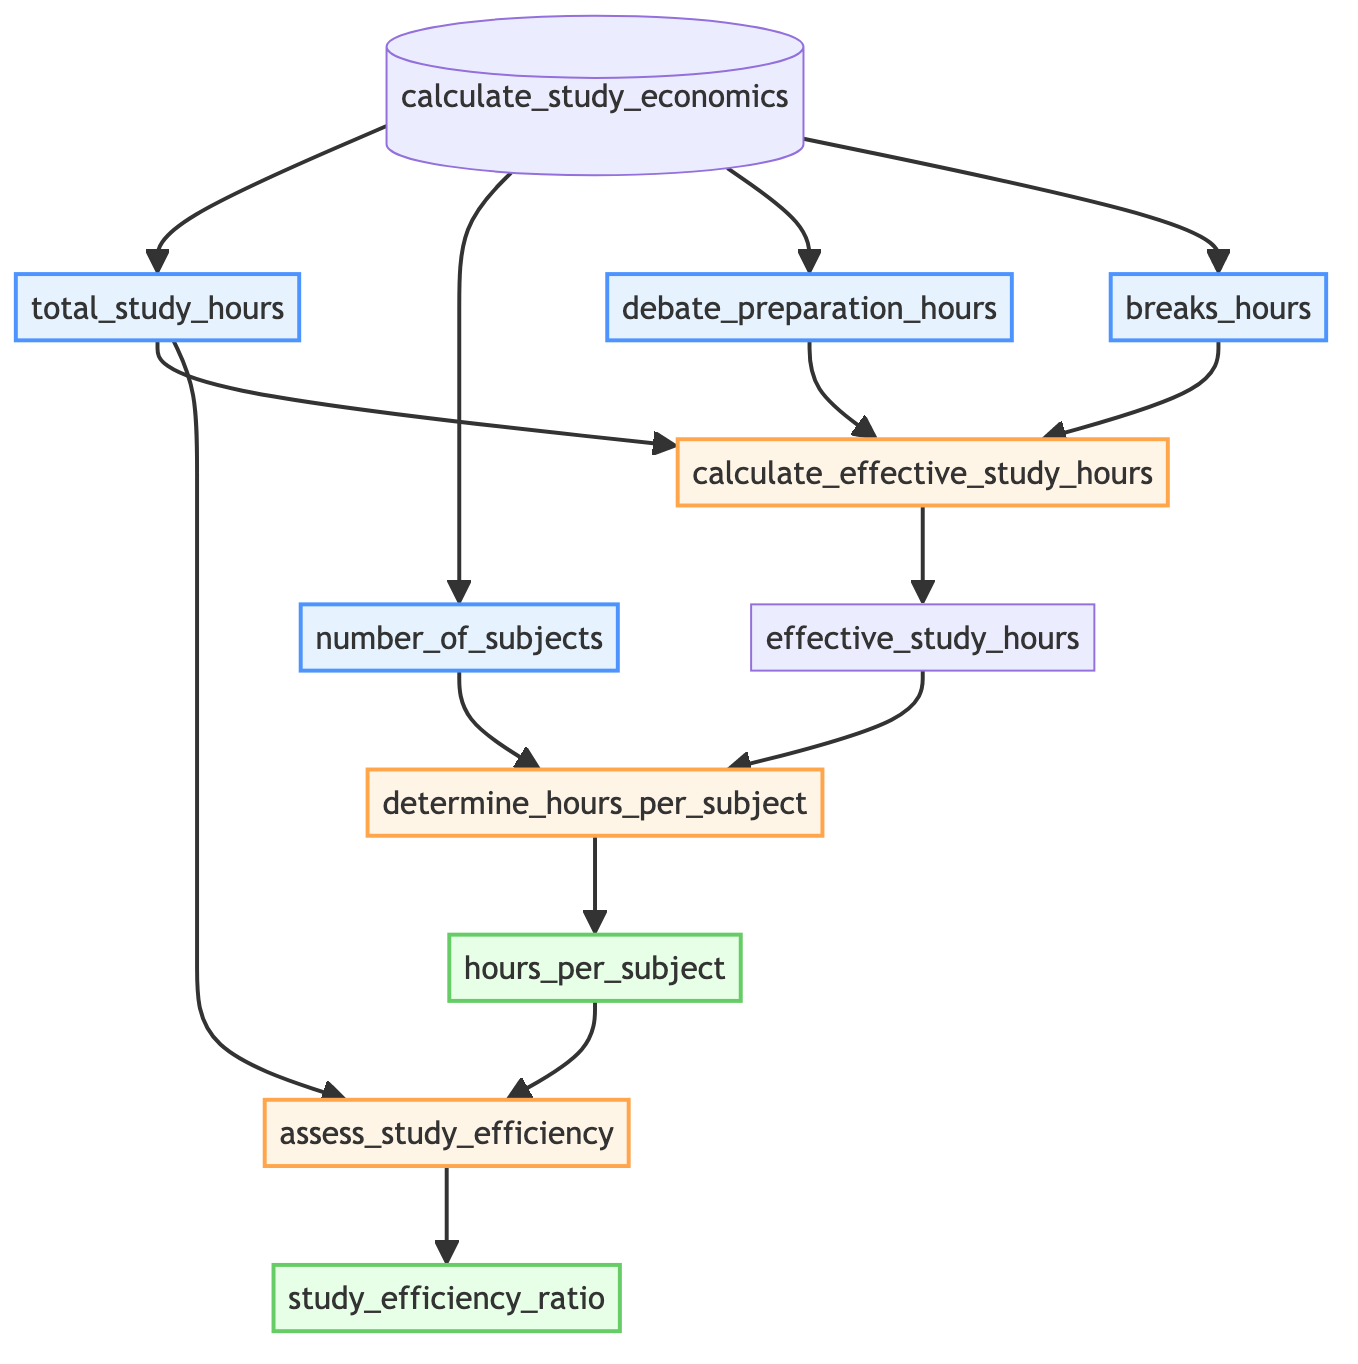what is the name of the function in this flowchart? The function name is indicated at the top of the flowchart as "calculate_study_economics."
Answer: calculate_study_economics how many input parameters does the function have? The function has four input parameters listed at the beginning of the flowchart: total_study_hours, number_of_subjects, debate_preparation_hours, and breaks_hours.
Answer: 4 what operation is performed to find the effective study hours? The flowchart shows that effective study hours are calculated using the subtraction operation involving total study hours, debate preparation hours, and breaks hours.
Answer: subtraction which node produces the output hours per subject? The node that produces the output "hours_per_subject" is labeled "determine_hours_per_subject."
Answer: determine_hours_per_subject how does the function assess study efficiency? The function assesses study efficiency by dividing the output hours per subject by the total study hours, as indicated in the node labeled "assess_study_efficiency."
Answer: division what outputs are generated by this function? The function generates two outputs: "hours_per_subject" and "study_efficiency_ratio," both shown at the end of the flowchart.
Answer: hours_per_subject and study_efficiency_ratio how many steps are involved in calculating study economics? There are three steps involved in the function for calculating study economics as represented by the three process nodes in the flowchart.
Answer: 3 what is the relationship between effective study hours and the number of subjects? The relationship is that effective study hours are divided by the number of subjects to determine the hours allocated per subject, as indicated in the corresponding nodes of the flowchart.
Answer: division which input is not directly used to calculate hours per subject? The input "debate_preparation_hours" is not directly used in the calculation of hours per subject as it is part of the calculation of effective study hours.
Answer: debate_preparation_hours 